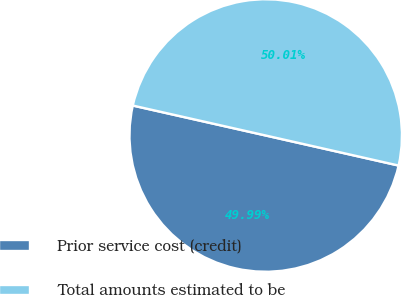Convert chart. <chart><loc_0><loc_0><loc_500><loc_500><pie_chart><fcel>Prior service cost (credit)<fcel>Total amounts estimated to be<nl><fcel>49.99%<fcel>50.01%<nl></chart> 